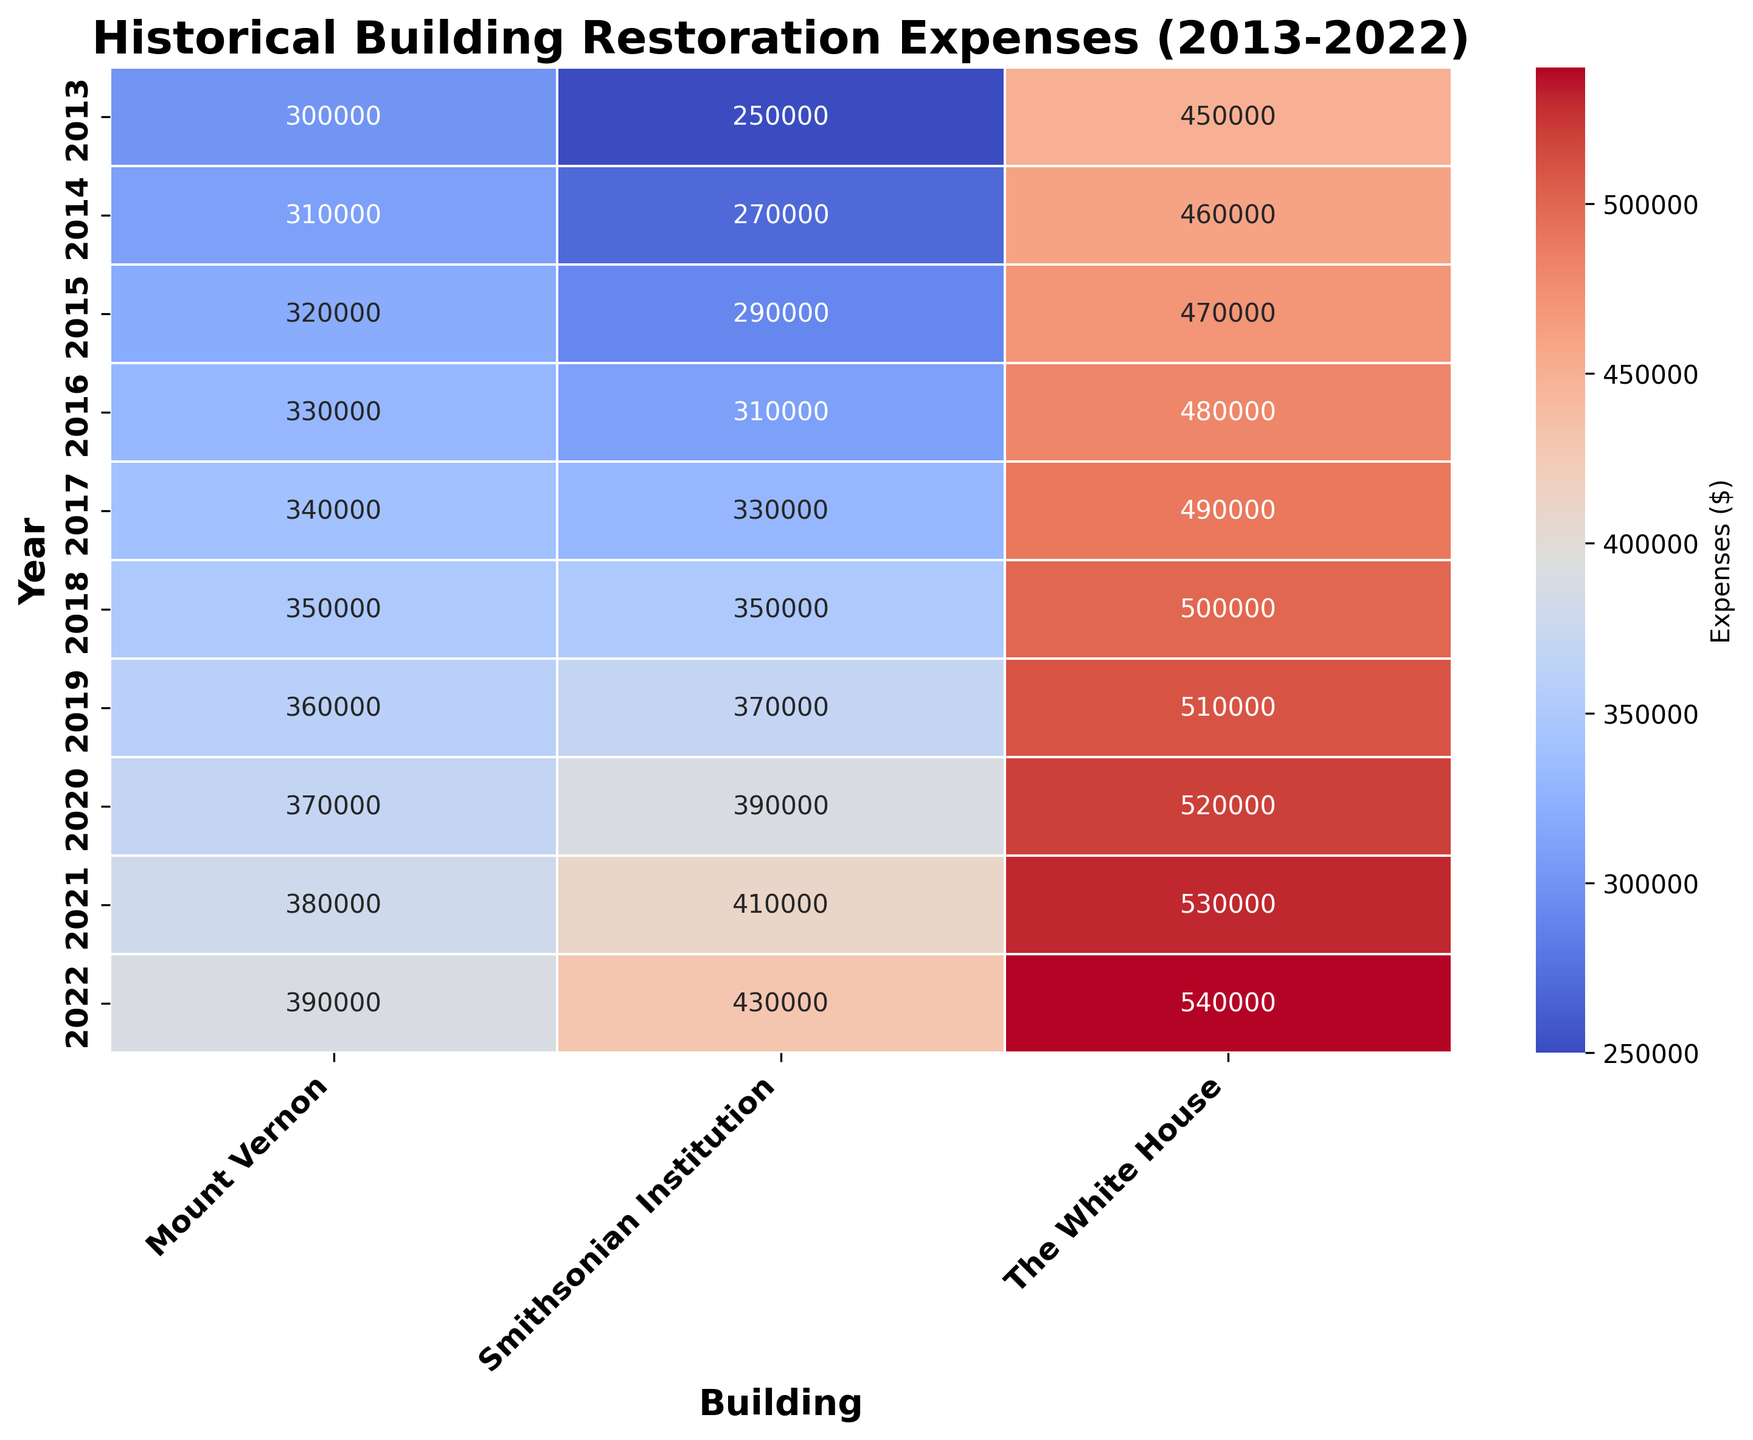what building had the highest restoration expenses in 2020? By examining the row corresponding to the year 2020, we can compare the expenses for each building. The highest value is for The White House with an expense of $520,000.
Answer: The White House what was the total restoration expense for the Smithsonian Institution from 2013 to 2022? By summing the values in the column for Smithsonian Institution, the total expense is calculated as $250,000 + $270,000 + $290,000 + $310,000 + $330,000 + $350,000 + $370,000 + $390,000 + $410,000 + $430,000 = $3,400,000.
Answer: $3,400,000 how much more was spent on Mount Vernon in 2022 compared to 2013? The expense for Mount Vernon in 2022 is $390,000 and in 2013 it is $300,000. By subtracting 300,000 from 390,000, we get $90,000.
Answer: $90,000 what was the average annual restoration expense for The White House over the decade? Summing the values for The White House from 2013 to 2022 gives $450,000 + $460,000 + $470,000 + $480,000 + $490,000 + $500,000 + $510,000 + $520,000 + $530,000 + $540,000 = $4,950,000. Dividing by 10 years, the average expense is $4,950,000 / 10 = $495,000.
Answer: $495,000 which year saw the lowest restoration expense for the Smithsonian Institution? By examining the values for each year in the Smithsonian Institution column, the lowest value is $250,000 in 2013.
Answer: 2013 which building showed the most consistent increase in restoration expenses over the decade? By observing the trend for each building, The White House shows a consistent increase in restoration expenses each year, without any decrease.
Answer: The White House in which year did Mount Vernon and The White House have equal restoration expenses? By comparing the values for Mount Vernon and The White House across all years, both have equal expenses of $350,000 in 2018.
Answer: 2018 what is the largest difference in annual restoration expenses between any two buildings in a single year? The largest difference can be observed by comparing individual annual expenses. In 2022, The White House spent $540,000, and Mount Vernon spent $390,000, making a difference of $150,000.
Answer: $150,000 how did the restoration expenses for Smithsonian Institution change from 2015 to 2016? Comparing the expenses in 2015 ($290,000) and 2016 ($310,000), the difference shows an increase of $20,000.
Answer: Increased by $20,000 what color intensity represents higher restoration expenses on the heatmap? In the heatmap using the coolwarm colormap, warmer colors (red shades) represent higher restoration expenses, while cooler colors (blue shades) denote lower expenses.
Answer: Red shades 